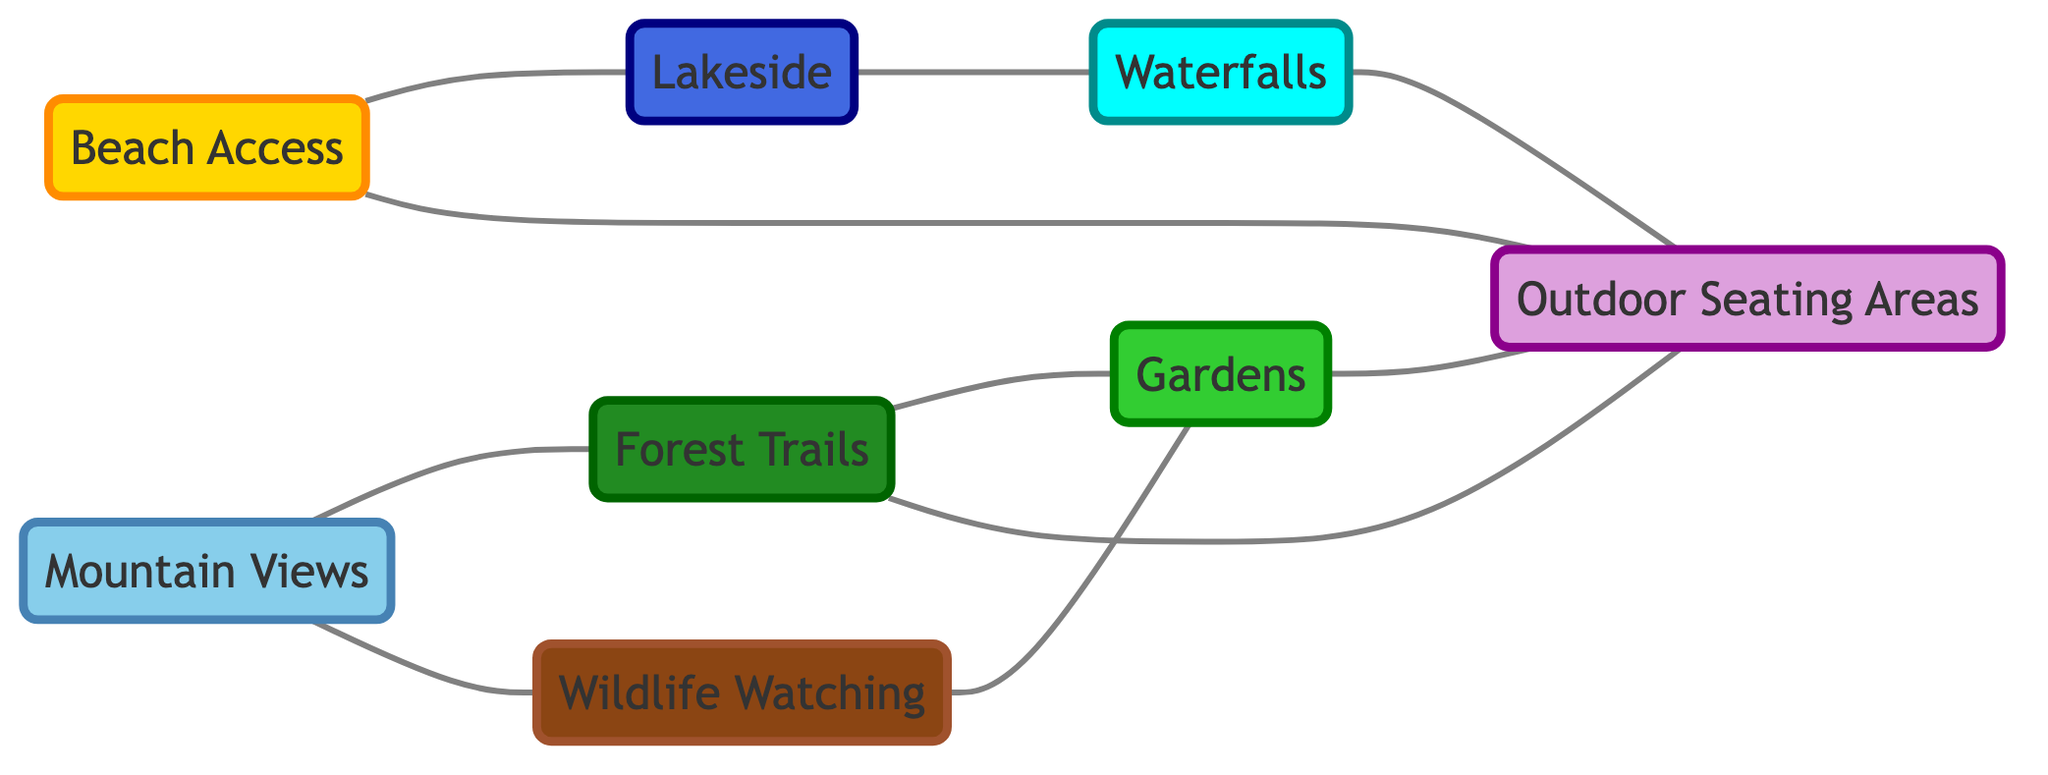How many nodes are in the diagram? To determine the number of nodes, we count each distinct feature listed in the "nodes" section of the data. There are 8 features present.
Answer: 8 Which features are connected to Beach Access? By examining the edges connected to Beach Access (node 1), we see it connects to Lakeside (node 4) and Outdoor Seating Areas (node 8).
Answer: Lakeside, Outdoor Seating Areas What is the connection between Mountain Views and Forest Trails? The diagram shows a connection (an edge) between Mountain Views (node 2) and Forest Trails (node 3). This means that guests who prefer one often also have a preference for the other.
Answer: Connected Which feature connects both Wildlife Watching and Gardens? To find this, we look for a node that has edges leading to both Wildlife Watching (node 5) and Gardens (node 6). The connecting node is Forest Trails (node 3), as it connects to both features.
Answer: Forest Trails What is the total number of edges in the diagram? To find the total number of edges, we count each connection listed in the "edges" section. There are 10 edges shown.
Answer: 10 Which natural feature has the most connections? To identify the feature with the most connections, we examine the number of edges each node has. The feature Outdoor Seating Areas (node 8) connects to Beach Access (node 1), Forest Trails (node 3), Gardens (node 6), and Waterfalls (node 7), totaling 4 connections.
Answer: Outdoor Seating Areas Does Lakeside have a direct connection to Forest Trails? By checking the edges, we see that there is no direct edge connecting Lakeside (node 4) and Forest Trails (node 3). Thus, they are not directly connected.
Answer: No Which features are directly connected to Waterfalls? Looking at the edges connected to Waterfalls (node 7), we see it connects only with Outdoor Seating Areas (node 8). Thus, that is the only feature directly linked to Waterfalls.
Answer: Outdoor Seating Areas 